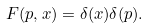<formula> <loc_0><loc_0><loc_500><loc_500>F ( p , x ) = \delta ( x ) \delta ( p ) .</formula> 